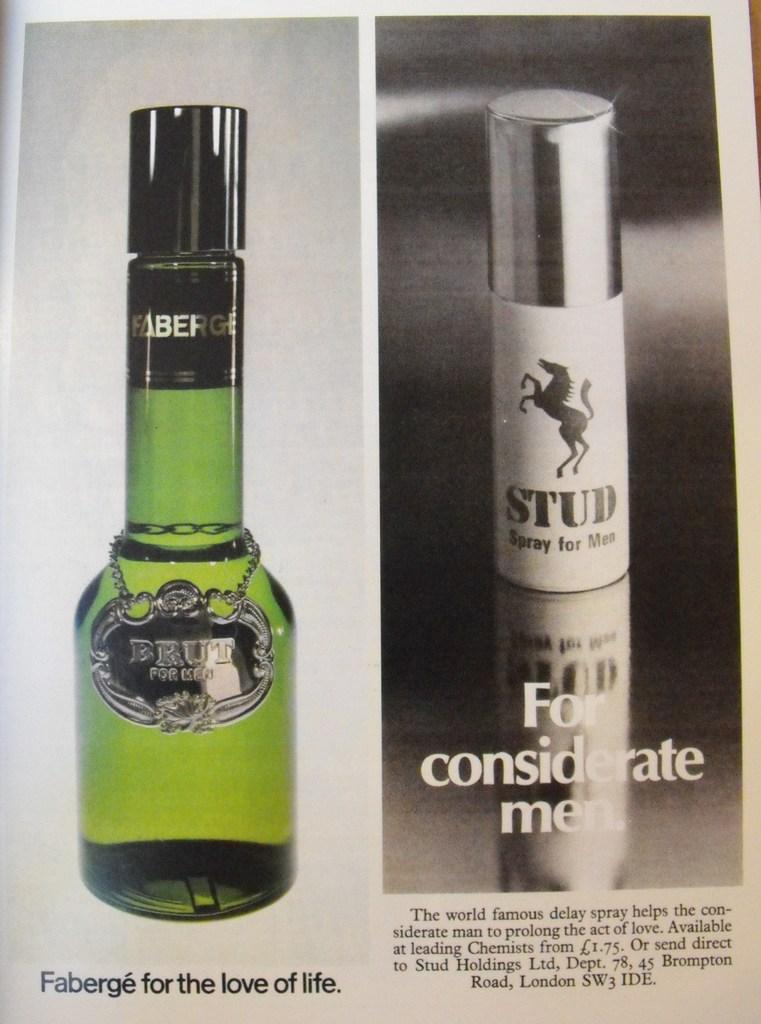<image>
Give a short and clear explanation of the subsequent image. Two bottles of aftershave, the one on the left being Brut. 